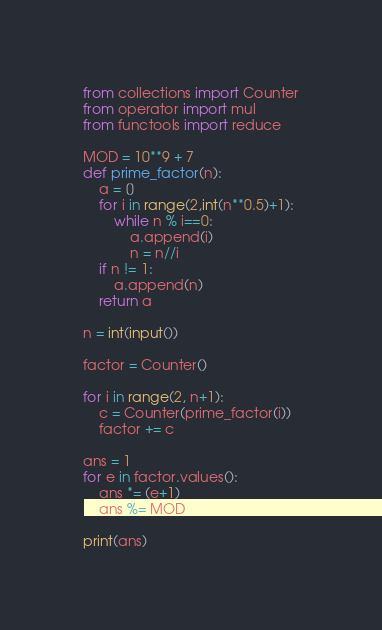Convert code to text. <code><loc_0><loc_0><loc_500><loc_500><_Python_>from collections import Counter
from operator import mul
from functools import reduce

MOD = 10**9 + 7
def prime_factor(n):
    a = []
    for i in range(2,int(n**0.5)+1):
        while n % i==0:
            a.append(i)
            n = n//i
    if n != 1:
        a.append(n)
    return a

n = int(input())

factor = Counter()

for i in range(2, n+1):
    c = Counter(prime_factor(i))
    factor += c

ans = 1
for e in factor.values():
    ans *= (e+1)
    ans %= MOD

print(ans)</code> 